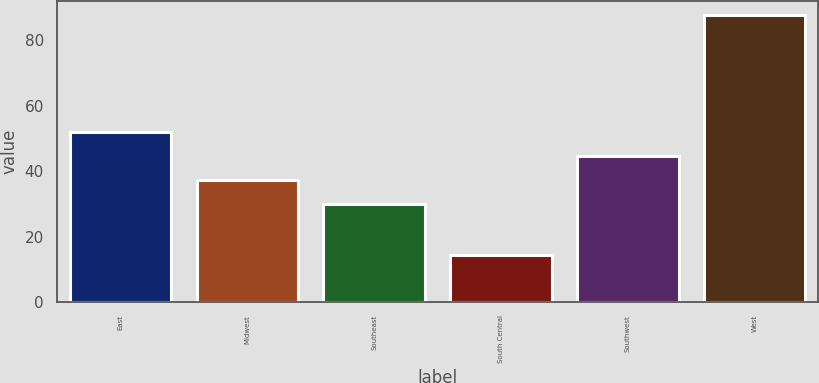Convert chart. <chart><loc_0><loc_0><loc_500><loc_500><bar_chart><fcel>East<fcel>Midwest<fcel>Southeast<fcel>South Central<fcel>Southwest<fcel>West<nl><fcel>51.79<fcel>37.13<fcel>29.8<fcel>14.2<fcel>44.46<fcel>87.5<nl></chart> 